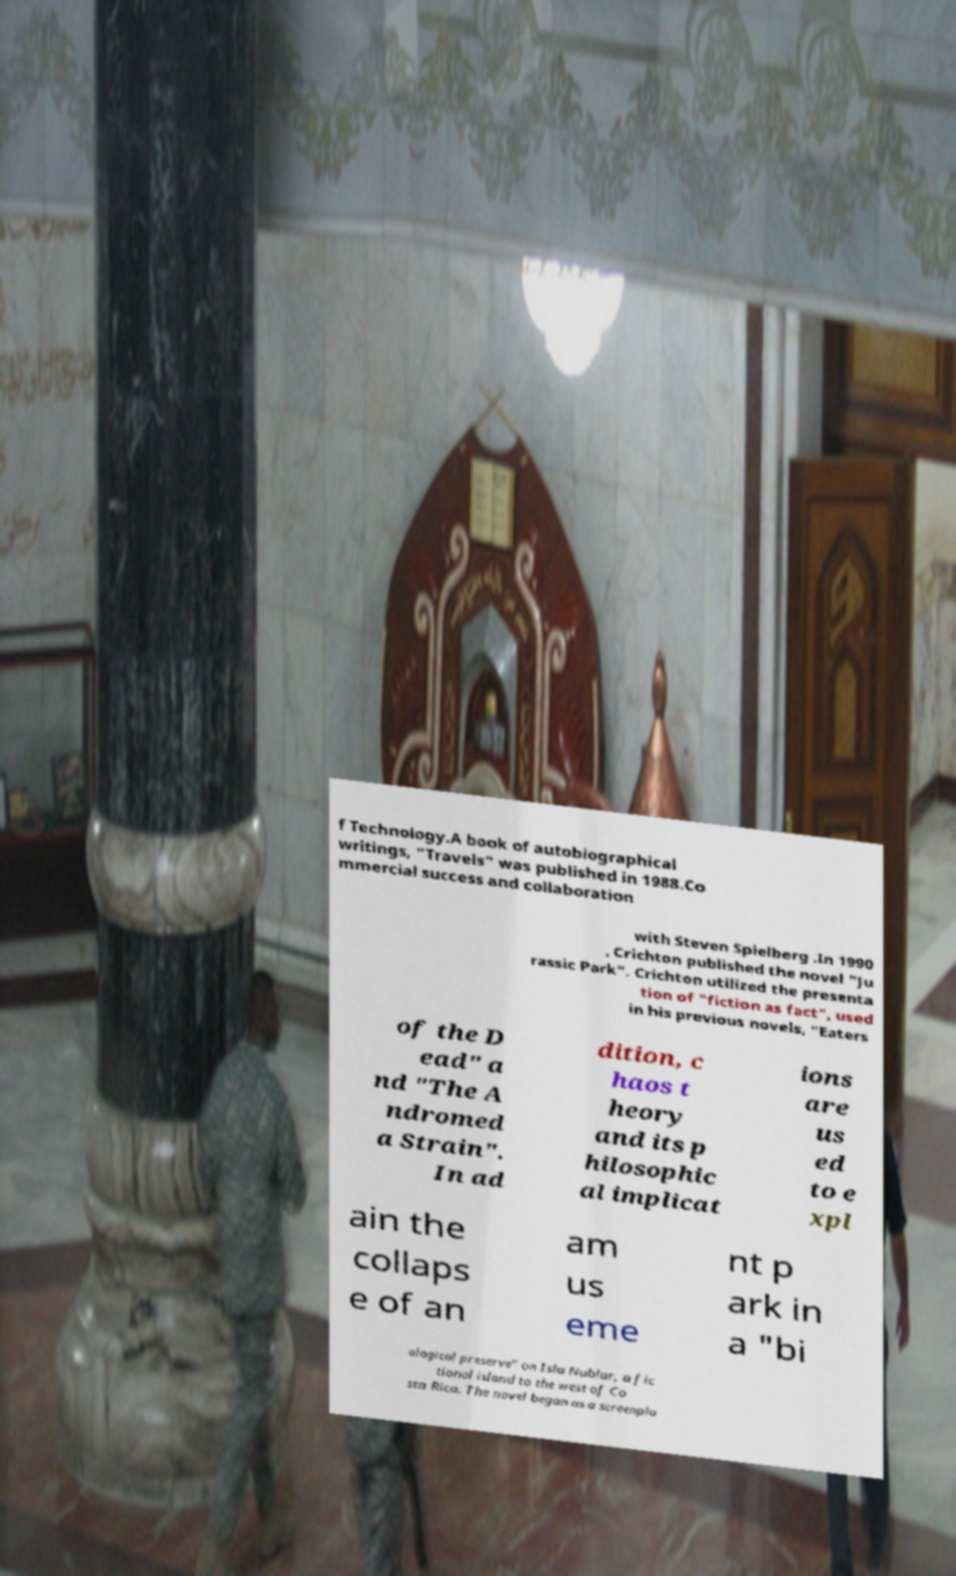Could you assist in decoding the text presented in this image and type it out clearly? f Technology.A book of autobiographical writings, "Travels" was published in 1988.Co mmercial success and collaboration with Steven Spielberg .In 1990 , Crichton published the novel "Ju rassic Park". Crichton utilized the presenta tion of "fiction as fact", used in his previous novels, "Eaters of the D ead" a nd "The A ndromed a Strain". In ad dition, c haos t heory and its p hilosophic al implicat ions are us ed to e xpl ain the collaps e of an am us eme nt p ark in a "bi ological preserve" on Isla Nublar, a fic tional island to the west of Co sta Rica. The novel began as a screenpla 